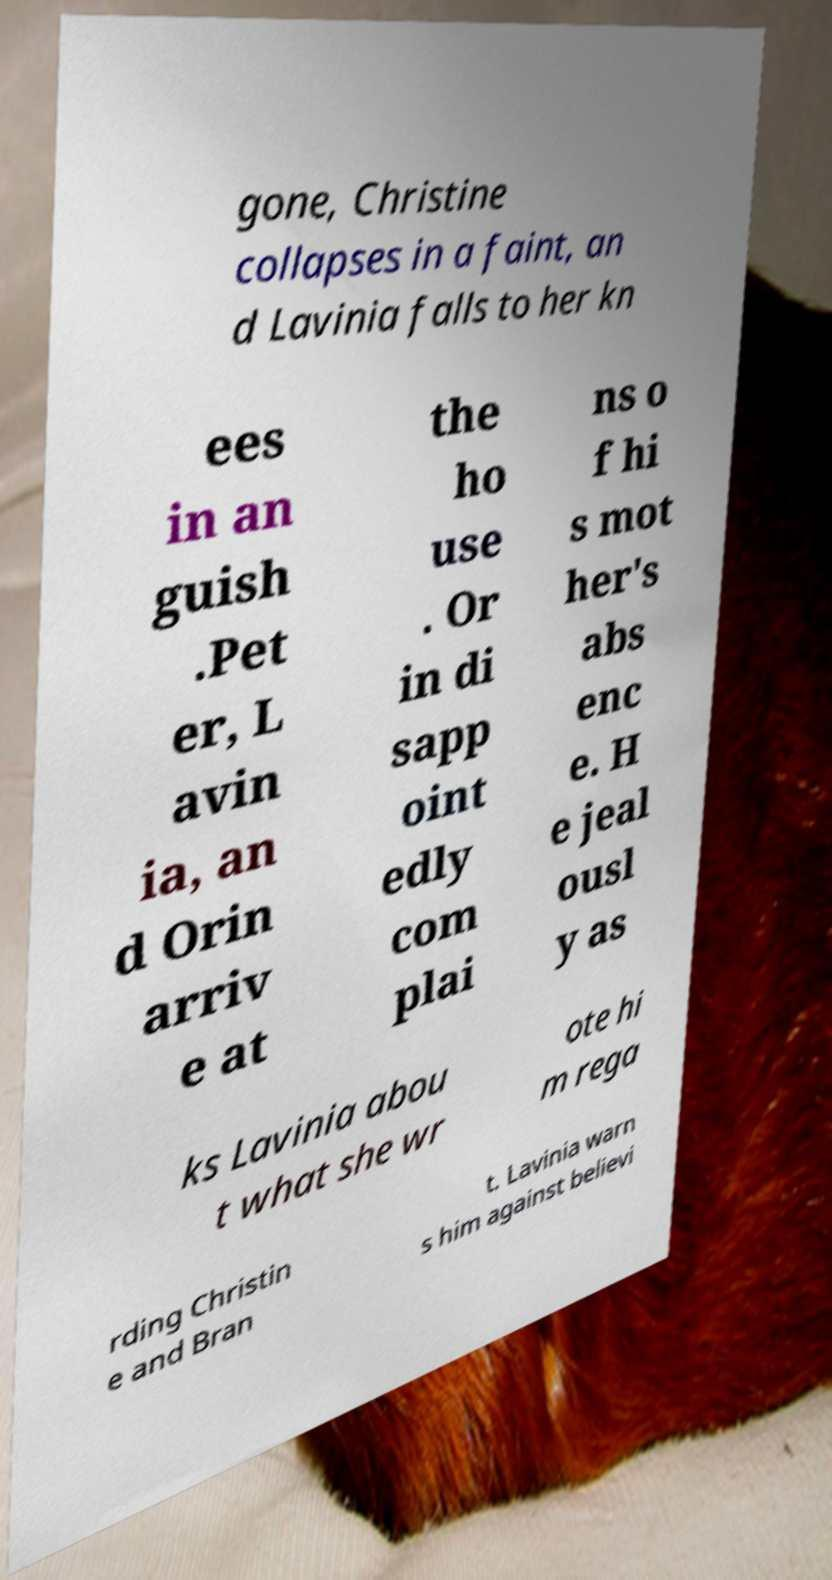I need the written content from this picture converted into text. Can you do that? gone, Christine collapses in a faint, an d Lavinia falls to her kn ees in an guish .Pet er, L avin ia, an d Orin arriv e at the ho use . Or in di sapp oint edly com plai ns o f hi s mot her's abs enc e. H e jeal ousl y as ks Lavinia abou t what she wr ote hi m rega rding Christin e and Bran t. Lavinia warn s him against believi 